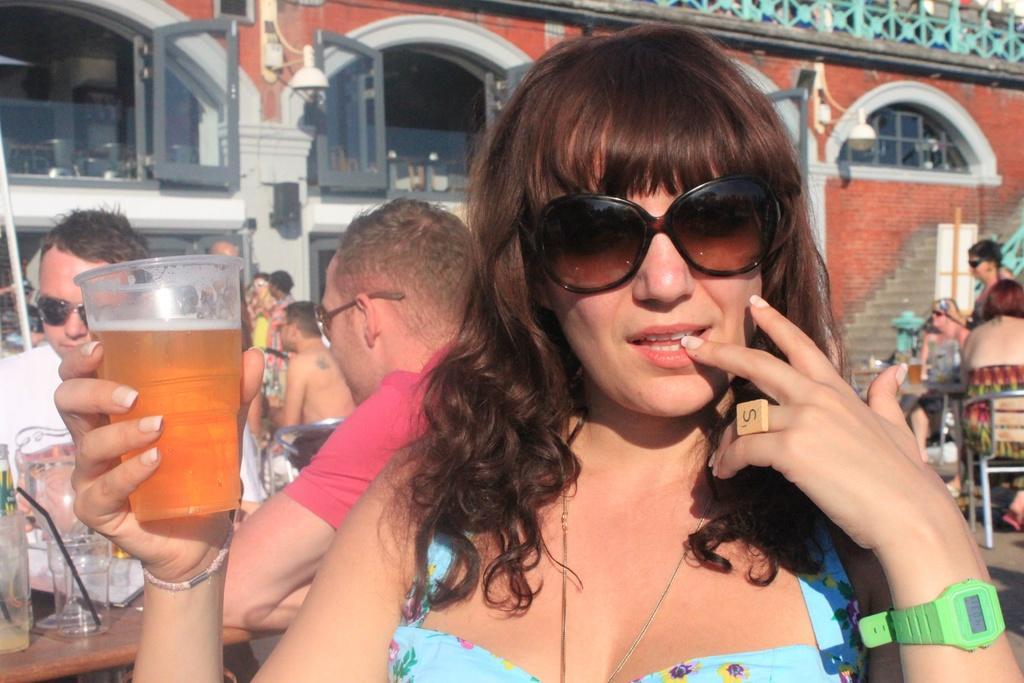Please provide a concise description of this image. This is the woman sitting and holding a glass of liquid in her hand. In the background, I can see groups of people sitting. This is a building with the windows and glass doors. I think these are the stairs. On the left side of the image, I can see a table with the glasses, a bottle and few other things on it. 